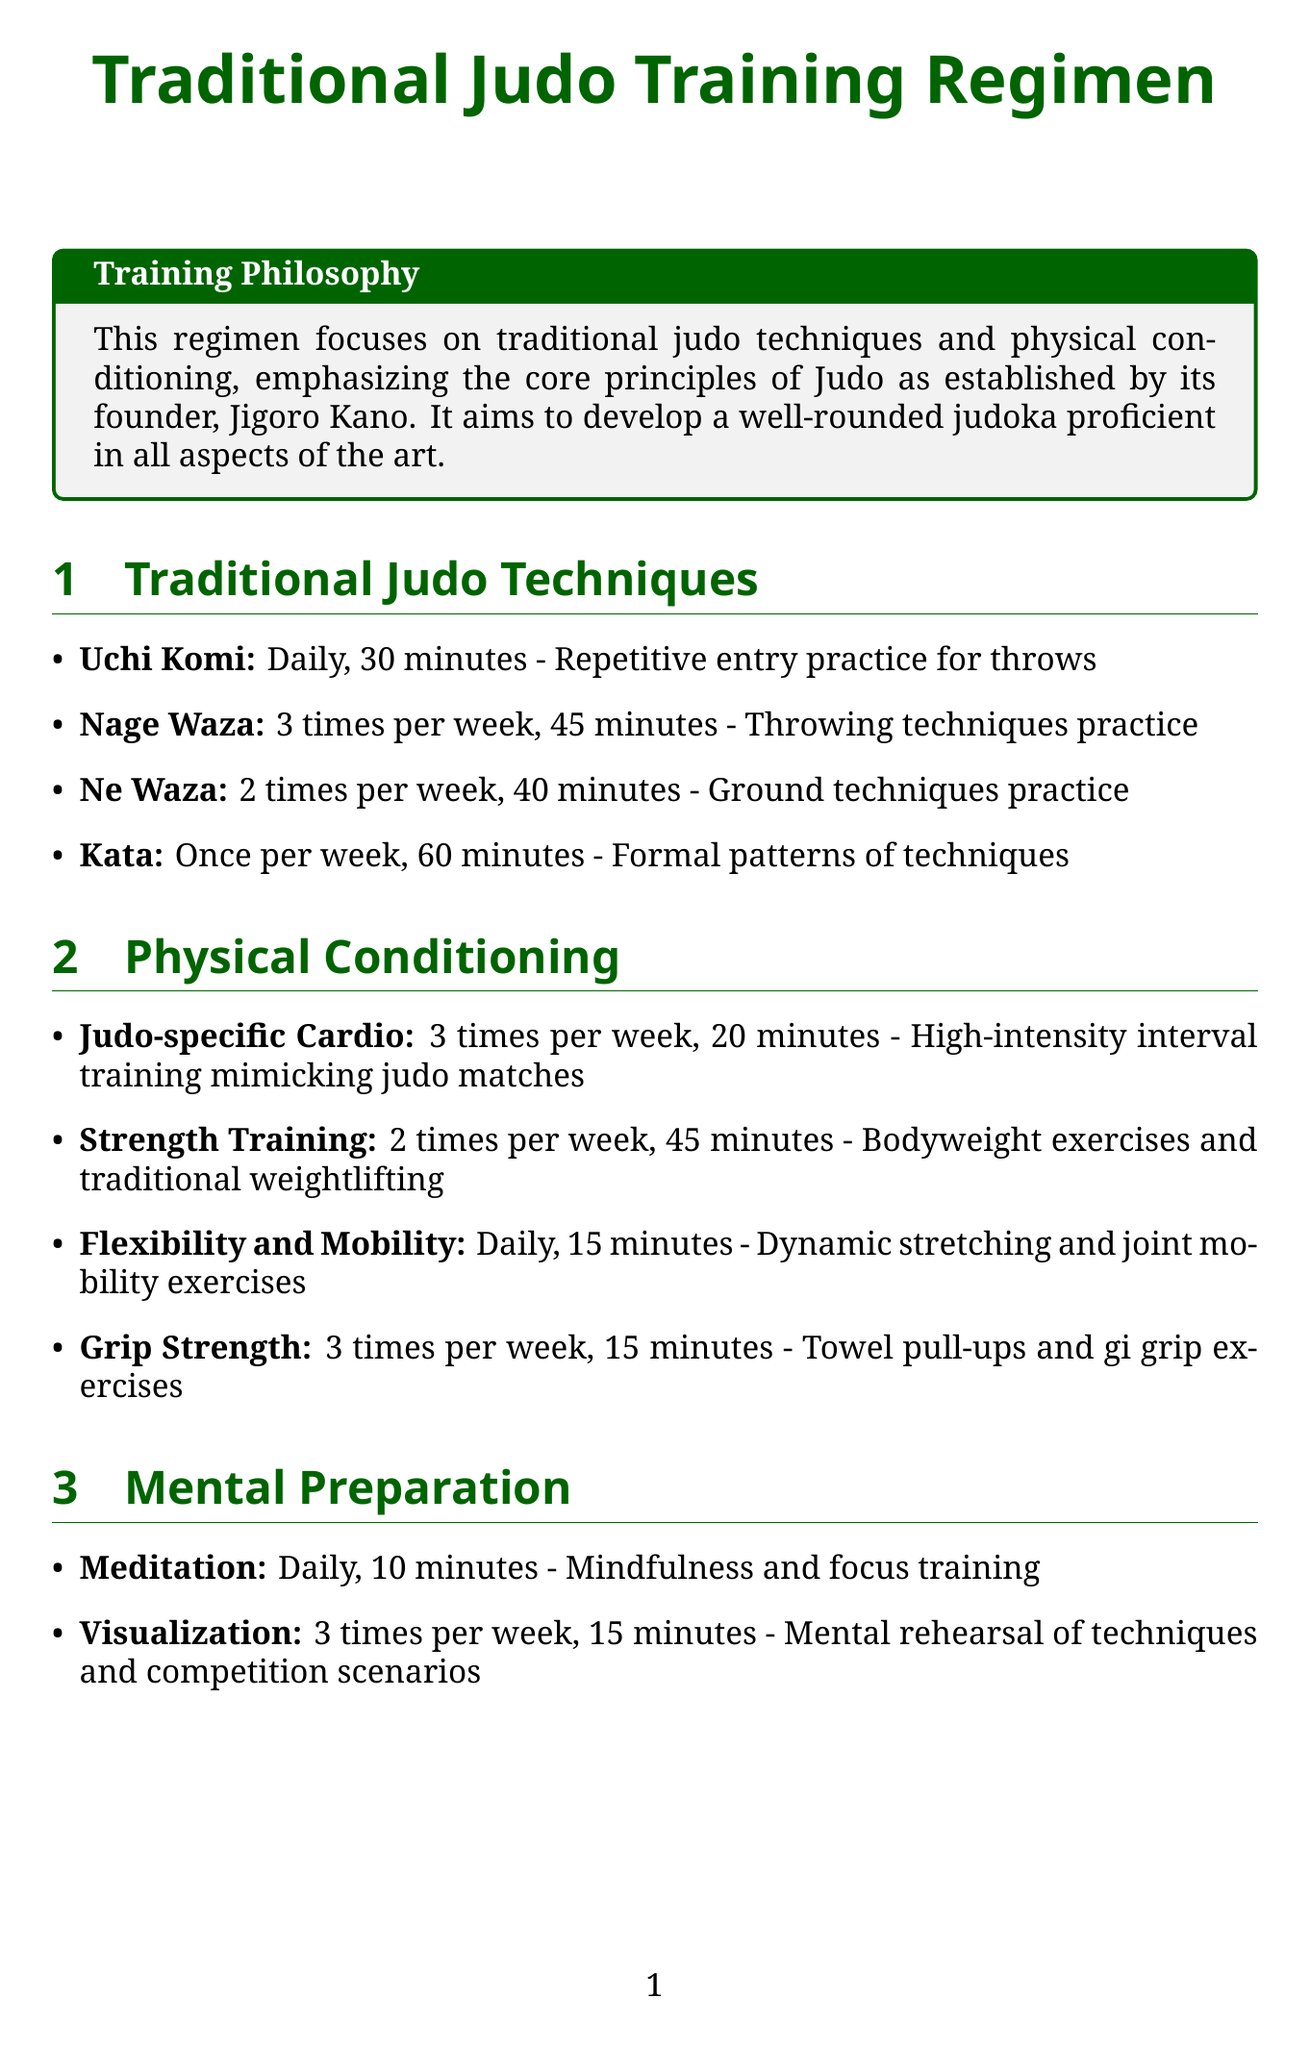What is the duration of Uchi Komi practice? Uchi Komi practice is specified to be 30 minutes in the regimen.
Answer: 30 minutes How many times per week is Nage Waza practiced? The regimen states that Nage Waza is practiced 3 times per week.
Answer: 3 times per week What type of exercises are included in Strength Training? Strength Training includes bodyweight exercises and traditional weightlifting as mentioned in the document.
Answer: Bodyweight exercises and traditional weightlifting How long is the Meditation practice every day? The document states that Meditation practice is 10 minutes long each day.
Answer: 10 minutes What is the frequency of Dojo Etiquette Review? Dojo Etiquette Review occurs once per week according to the schedule.
Answer: Once per week In total, how many days a week includes physical conditioning activities? Physical conditioning activities occur 6 days a week, as inferred from their frequencies.
Answer: 6 days a week What is the aim of the Training Philosophy in the document? The Training Philosophy aims to develop a well-rounded judoka proficient in all aspects of the art.
Answer: Develop a well-rounded judoka Which mental preparation technique is done daily? The document lists Meditation as the mental preparation technique practiced daily.
Answer: Meditation How often is an Ice Bath recommended in the recovery section? The Ice Bath is recommended 2 times per week as stated in the document.
Answer: 2 times per week 